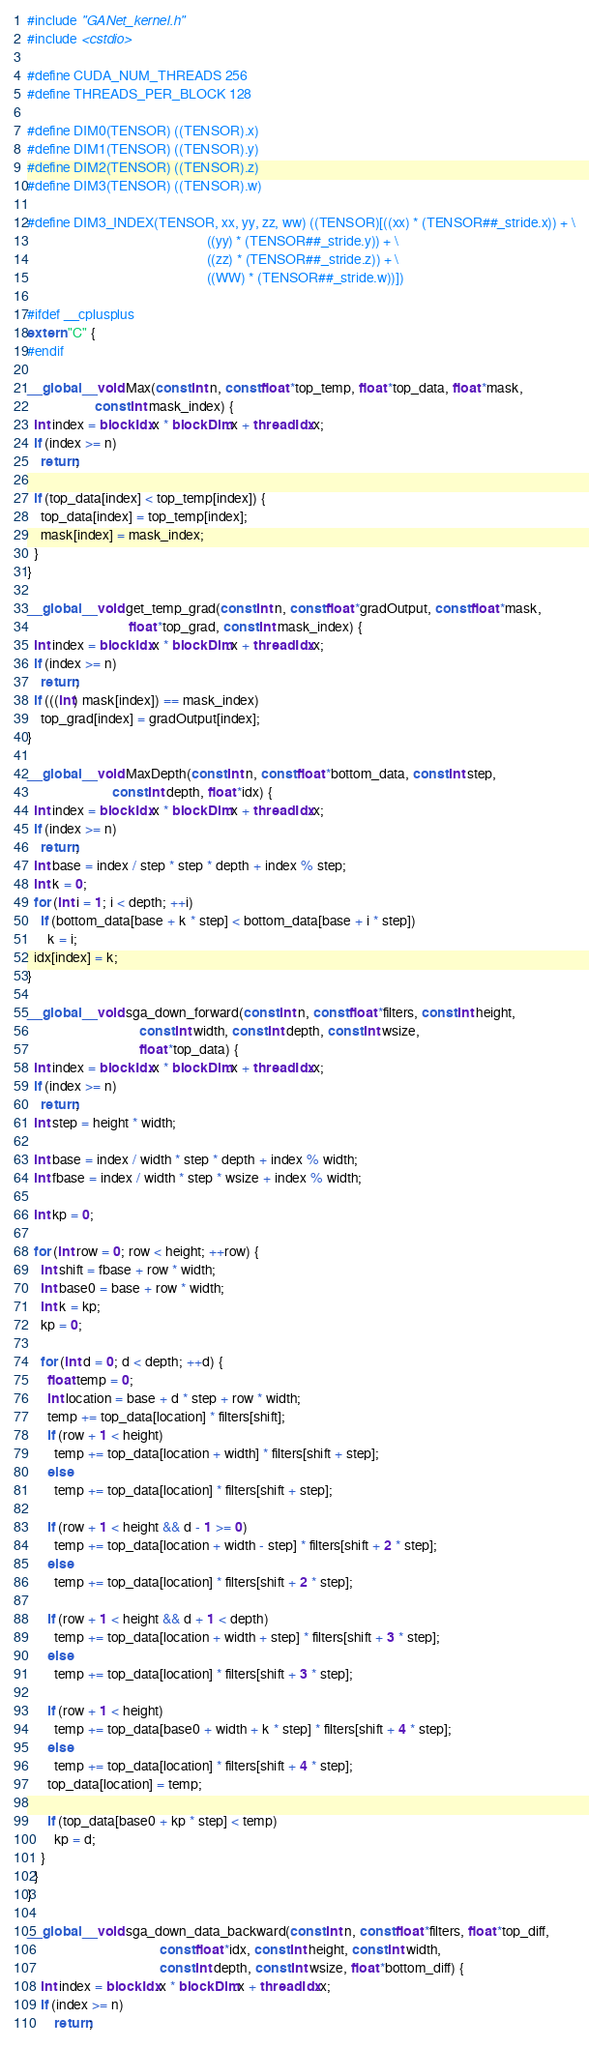<code> <loc_0><loc_0><loc_500><loc_500><_Cuda_>#include "GANet_kernel.h"
#include <cstdio>

#define CUDA_NUM_THREADS 256
#define THREADS_PER_BLOCK 128

#define DIM0(TENSOR) ((TENSOR).x)
#define DIM1(TENSOR) ((TENSOR).y)
#define DIM2(TENSOR) ((TENSOR).z)
#define DIM3(TENSOR) ((TENSOR).w)

#define DIM3_INDEX(TENSOR, xx, yy, zz, ww) ((TENSOR)[((xx) * (TENSOR##_stride.x)) + \
                                                     ((yy) * (TENSOR##_stride.y)) + \
                                                     ((zz) * (TENSOR##_stride.z)) + \
                                                     ((WW) * (TENSOR##_stride.w))])

#ifdef __cplusplus
extern "C" {
#endif

__global__ void Max(const int n, const float *top_temp, float *top_data, float *mask,
                    const int mask_index) {
  int index = blockIdx.x * blockDim.x + threadIdx.x;
  if (index >= n)
    return;

  if (top_data[index] < top_temp[index]) {
    top_data[index] = top_temp[index];
    mask[index] = mask_index;
  }
}

__global__ void get_temp_grad(const int n, const float *gradOutput, const float *mask,
                              float *top_grad, const int mask_index) {
  int index = blockIdx.x * blockDim.x + threadIdx.x;
  if (index >= n)
    return;
  if (((int) mask[index]) == mask_index)
    top_grad[index] = gradOutput[index];
}

__global__ void MaxDepth(const int n, const float *bottom_data, const int step,
                         const int depth, float *idx) {
  int index = blockIdx.x * blockDim.x + threadIdx.x;
  if (index >= n)
    return;
  int base = index / step * step * depth + index % step;
  int k = 0;
  for (int i = 1; i < depth; ++i)
    if (bottom_data[base + k * step] < bottom_data[base + i * step])
      k = i;
  idx[index] = k;
}

__global__ void sga_down_forward(const int n, const float *filters, const int height,
                                 const int width, const int depth, const int wsize,
                                 float *top_data) {
  int index = blockIdx.x * blockDim.x + threadIdx.x;
  if (index >= n)
    return;
  int step = height * width;

  int base = index / width * step * depth + index % width;
  int fbase = index / width * step * wsize + index % width;

  int kp = 0;

  for (int row = 0; row < height; ++row) {
    int shift = fbase + row * width;
    int base0 = base + row * width;
    int k = kp;
    kp = 0;

    for (int d = 0; d < depth; ++d) {
      float temp = 0;
      int location = base + d * step + row * width;
      temp += top_data[location] * filters[shift];
      if (row + 1 < height)
        temp += top_data[location + width] * filters[shift + step];
      else
        temp += top_data[location] * filters[shift + step];

      if (row + 1 < height && d - 1 >= 0)
        temp += top_data[location + width - step] * filters[shift + 2 * step];
      else
        temp += top_data[location] * filters[shift + 2 * step];

      if (row + 1 < height && d + 1 < depth)
        temp += top_data[location + width + step] * filters[shift + 3 * step];
      else
        temp += top_data[location] * filters[shift + 3 * step];

      if (row + 1 < height)
        temp += top_data[base0 + width + k * step] * filters[shift + 4 * step];
      else
        temp += top_data[location] * filters[shift + 4 * step];
      top_data[location] = temp;

      if (top_data[base0 + kp * step] < temp)
        kp = d;
    }
  }
}

__global__ void sga_down_data_backward(const int n, const float *filters, float *top_diff,
                                       const float *idx, const int height, const int width,
                                       const int depth, const int wsize, float *bottom_diff) {
    int index = blockIdx.x * blockDim.x + threadIdx.x;
    if (index >= n)
        return;
</code> 